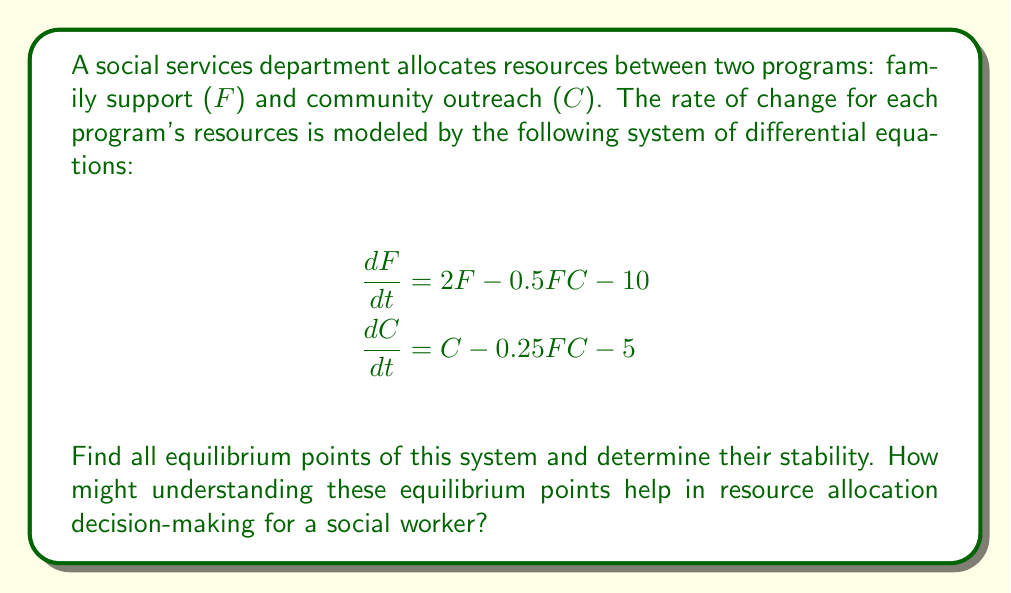Show me your answer to this math problem. 1) To find equilibrium points, set both equations to zero:

   $$2F - 0.5FC - 10 = 0$$
   $$C - 0.25FC - 5 = 0$$

2) From the second equation:
   $$C(1 - 0.25F) = 5$$
   $$C = \frac{5}{1 - 0.25F}$$

3) Substitute this into the first equation:
   $$2F - 0.5F(\frac{5}{1 - 0.25F}) - 10 = 0$$

4) Simplify:
   $$2F - \frac{2.5F}{1 - 0.25F} - 10 = 0$$
   $$2F(1 - 0.25F) - 2.5F - 10(1 - 0.25F) = 0$$
   $$2F - 0.5F^2 - 2.5F - 10 + 2.5F = 0$$
   $$-0.5F^2 + 2F - 10 = 0$$

5) Solve this quadratic equation:
   $$F = \frac{-2 \pm \sqrt{4 + 20}}{-1} = \frac{-2 \pm \sqrt{24}}{-1} = \frac{-2 \pm 2\sqrt{6}}{-1}$$

6) This gives two equilibrium points:
   $$F_1 = 2 + \sqrt{6}, \quad C_1 = \frac{5}{1 - 0.25(2 + \sqrt{6})} \approx 10.46$$
   $$F_2 = 2 - \sqrt{6}, \quad C_2 = \frac{5}{1 - 0.25(2 - \sqrt{6})} \approx 3.54$$

7) To determine stability, we need to find the Jacobian matrix:
   $$J = \begin{bmatrix}
   2 - 0.5C & -0.5F \\
   -0.25C & 1 - 0.25F
   \end{bmatrix}$$

8) Evaluate the Jacobian at each equilibrium point and find its eigenvalues. If all eigenvalues have negative real parts, the point is stable.

9) For the point $(F_1, C_1)$, the eigenvalues are approximately -1.37 and -0.63, indicating a stable equilibrium.

10) For the point $(F_2, C_2)$, the eigenvalues are approximately 1.37 and 0.63, indicating an unstable equilibrium.

Understanding these equilibrium points helps a social worker in resource allocation by identifying the stable balance between family support and community outreach programs. The stable equilibrium suggests a sustainable allocation, while the unstable point indicates a less desirable state that the system will naturally move away from.
Answer: Two equilibrium points: (2 + √6, 10.46) stable, (2 - √6, 3.54) unstable. 